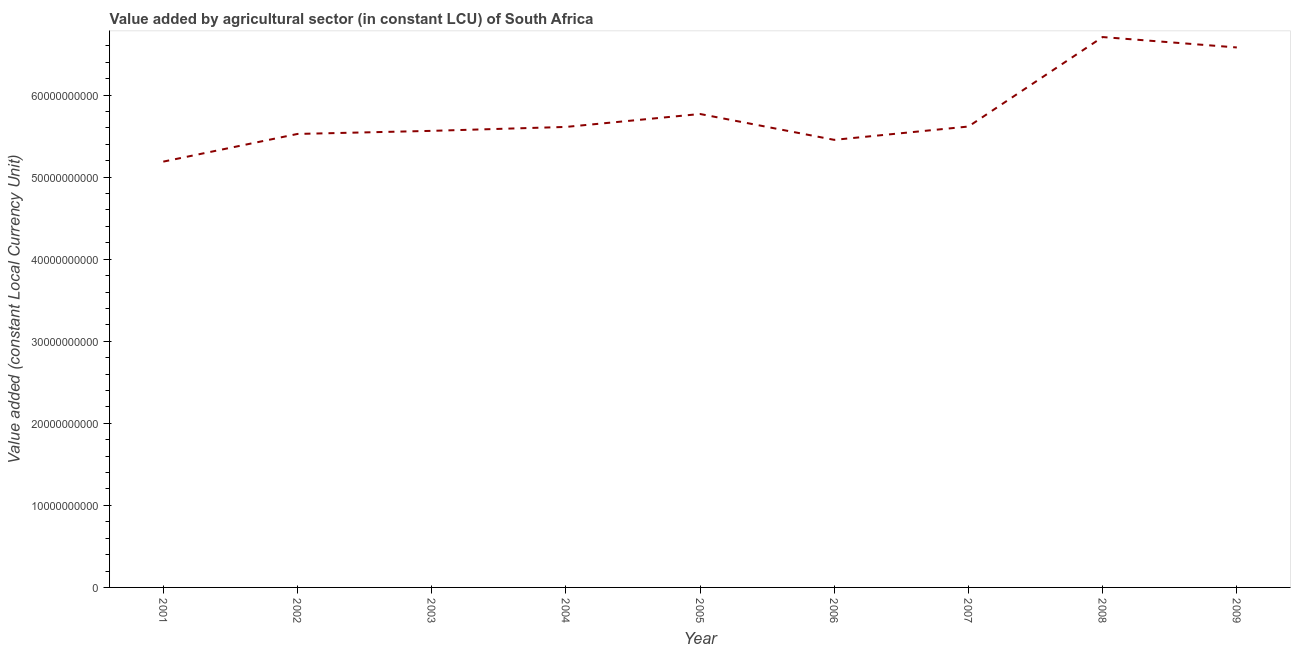What is the value added by agriculture sector in 2009?
Provide a short and direct response. 6.58e+1. Across all years, what is the maximum value added by agriculture sector?
Offer a terse response. 6.71e+1. Across all years, what is the minimum value added by agriculture sector?
Provide a short and direct response. 5.19e+1. In which year was the value added by agriculture sector minimum?
Give a very brief answer. 2001. What is the sum of the value added by agriculture sector?
Provide a succinct answer. 5.20e+11. What is the difference between the value added by agriculture sector in 2003 and 2004?
Make the answer very short. -4.78e+08. What is the average value added by agriculture sector per year?
Your answer should be compact. 5.78e+1. What is the median value added by agriculture sector?
Make the answer very short. 5.61e+1. In how many years, is the value added by agriculture sector greater than 12000000000 LCU?
Keep it short and to the point. 9. What is the ratio of the value added by agriculture sector in 2004 to that in 2007?
Provide a succinct answer. 1. Is the value added by agriculture sector in 2001 less than that in 2007?
Provide a short and direct response. Yes. What is the difference between the highest and the second highest value added by agriculture sector?
Make the answer very short. 1.27e+09. Is the sum of the value added by agriculture sector in 2001 and 2005 greater than the maximum value added by agriculture sector across all years?
Offer a very short reply. Yes. What is the difference between the highest and the lowest value added by agriculture sector?
Provide a short and direct response. 1.52e+1. Does the value added by agriculture sector monotonically increase over the years?
Keep it short and to the point. No. What is the difference between two consecutive major ticks on the Y-axis?
Provide a short and direct response. 1.00e+1. Are the values on the major ticks of Y-axis written in scientific E-notation?
Provide a succinct answer. No. What is the title of the graph?
Offer a very short reply. Value added by agricultural sector (in constant LCU) of South Africa. What is the label or title of the X-axis?
Provide a succinct answer. Year. What is the label or title of the Y-axis?
Your answer should be very brief. Value added (constant Local Currency Unit). What is the Value added (constant Local Currency Unit) in 2001?
Keep it short and to the point. 5.19e+1. What is the Value added (constant Local Currency Unit) in 2002?
Offer a terse response. 5.53e+1. What is the Value added (constant Local Currency Unit) of 2003?
Provide a succinct answer. 5.56e+1. What is the Value added (constant Local Currency Unit) in 2004?
Provide a succinct answer. 5.61e+1. What is the Value added (constant Local Currency Unit) of 2005?
Keep it short and to the point. 5.77e+1. What is the Value added (constant Local Currency Unit) of 2006?
Offer a very short reply. 5.45e+1. What is the Value added (constant Local Currency Unit) in 2007?
Provide a succinct answer. 5.62e+1. What is the Value added (constant Local Currency Unit) in 2008?
Provide a short and direct response. 6.71e+1. What is the Value added (constant Local Currency Unit) of 2009?
Keep it short and to the point. 6.58e+1. What is the difference between the Value added (constant Local Currency Unit) in 2001 and 2002?
Provide a short and direct response. -3.37e+09. What is the difference between the Value added (constant Local Currency Unit) in 2001 and 2003?
Provide a succinct answer. -3.75e+09. What is the difference between the Value added (constant Local Currency Unit) in 2001 and 2004?
Ensure brevity in your answer.  -4.23e+09. What is the difference between the Value added (constant Local Currency Unit) in 2001 and 2005?
Make the answer very short. -5.80e+09. What is the difference between the Value added (constant Local Currency Unit) in 2001 and 2006?
Ensure brevity in your answer.  -2.65e+09. What is the difference between the Value added (constant Local Currency Unit) in 2001 and 2007?
Ensure brevity in your answer.  -4.28e+09. What is the difference between the Value added (constant Local Currency Unit) in 2001 and 2008?
Your response must be concise. -1.52e+1. What is the difference between the Value added (constant Local Currency Unit) in 2001 and 2009?
Your answer should be very brief. -1.39e+1. What is the difference between the Value added (constant Local Currency Unit) in 2002 and 2003?
Provide a succinct answer. -3.76e+08. What is the difference between the Value added (constant Local Currency Unit) in 2002 and 2004?
Your answer should be compact. -8.55e+08. What is the difference between the Value added (constant Local Currency Unit) in 2002 and 2005?
Provide a short and direct response. -2.43e+09. What is the difference between the Value added (constant Local Currency Unit) in 2002 and 2006?
Offer a terse response. 7.20e+08. What is the difference between the Value added (constant Local Currency Unit) in 2002 and 2007?
Offer a terse response. -9.05e+08. What is the difference between the Value added (constant Local Currency Unit) in 2002 and 2008?
Give a very brief answer. -1.18e+1. What is the difference between the Value added (constant Local Currency Unit) in 2002 and 2009?
Offer a very short reply. -1.05e+1. What is the difference between the Value added (constant Local Currency Unit) in 2003 and 2004?
Provide a short and direct response. -4.78e+08. What is the difference between the Value added (constant Local Currency Unit) in 2003 and 2005?
Offer a very short reply. -2.06e+09. What is the difference between the Value added (constant Local Currency Unit) in 2003 and 2006?
Give a very brief answer. 1.10e+09. What is the difference between the Value added (constant Local Currency Unit) in 2003 and 2007?
Provide a short and direct response. -5.28e+08. What is the difference between the Value added (constant Local Currency Unit) in 2003 and 2008?
Keep it short and to the point. -1.14e+1. What is the difference between the Value added (constant Local Currency Unit) in 2003 and 2009?
Ensure brevity in your answer.  -1.02e+1. What is the difference between the Value added (constant Local Currency Unit) in 2004 and 2005?
Keep it short and to the point. -1.58e+09. What is the difference between the Value added (constant Local Currency Unit) in 2004 and 2006?
Keep it short and to the point. 1.57e+09. What is the difference between the Value added (constant Local Currency Unit) in 2004 and 2007?
Provide a succinct answer. -5.00e+07. What is the difference between the Value added (constant Local Currency Unit) in 2004 and 2008?
Your answer should be very brief. -1.10e+1. What is the difference between the Value added (constant Local Currency Unit) in 2004 and 2009?
Keep it short and to the point. -9.68e+09. What is the difference between the Value added (constant Local Currency Unit) in 2005 and 2006?
Your response must be concise. 3.15e+09. What is the difference between the Value added (constant Local Currency Unit) in 2005 and 2007?
Give a very brief answer. 1.53e+09. What is the difference between the Value added (constant Local Currency Unit) in 2005 and 2008?
Your response must be concise. -9.38e+09. What is the difference between the Value added (constant Local Currency Unit) in 2005 and 2009?
Make the answer very short. -8.11e+09. What is the difference between the Value added (constant Local Currency Unit) in 2006 and 2007?
Offer a terse response. -1.62e+09. What is the difference between the Value added (constant Local Currency Unit) in 2006 and 2008?
Offer a terse response. -1.25e+1. What is the difference between the Value added (constant Local Currency Unit) in 2006 and 2009?
Offer a terse response. -1.13e+1. What is the difference between the Value added (constant Local Currency Unit) in 2007 and 2008?
Provide a succinct answer. -1.09e+1. What is the difference between the Value added (constant Local Currency Unit) in 2007 and 2009?
Offer a terse response. -9.63e+09. What is the difference between the Value added (constant Local Currency Unit) in 2008 and 2009?
Offer a very short reply. 1.27e+09. What is the ratio of the Value added (constant Local Currency Unit) in 2001 to that in 2002?
Offer a terse response. 0.94. What is the ratio of the Value added (constant Local Currency Unit) in 2001 to that in 2003?
Give a very brief answer. 0.93. What is the ratio of the Value added (constant Local Currency Unit) in 2001 to that in 2004?
Offer a terse response. 0.93. What is the ratio of the Value added (constant Local Currency Unit) in 2001 to that in 2005?
Provide a succinct answer. 0.9. What is the ratio of the Value added (constant Local Currency Unit) in 2001 to that in 2006?
Provide a succinct answer. 0.95. What is the ratio of the Value added (constant Local Currency Unit) in 2001 to that in 2007?
Provide a short and direct response. 0.92. What is the ratio of the Value added (constant Local Currency Unit) in 2001 to that in 2008?
Your response must be concise. 0.77. What is the ratio of the Value added (constant Local Currency Unit) in 2001 to that in 2009?
Make the answer very short. 0.79. What is the ratio of the Value added (constant Local Currency Unit) in 2002 to that in 2003?
Provide a succinct answer. 0.99. What is the ratio of the Value added (constant Local Currency Unit) in 2002 to that in 2004?
Give a very brief answer. 0.98. What is the ratio of the Value added (constant Local Currency Unit) in 2002 to that in 2005?
Your response must be concise. 0.96. What is the ratio of the Value added (constant Local Currency Unit) in 2002 to that in 2008?
Provide a short and direct response. 0.82. What is the ratio of the Value added (constant Local Currency Unit) in 2002 to that in 2009?
Offer a very short reply. 0.84. What is the ratio of the Value added (constant Local Currency Unit) in 2003 to that in 2004?
Provide a succinct answer. 0.99. What is the ratio of the Value added (constant Local Currency Unit) in 2003 to that in 2007?
Keep it short and to the point. 0.99. What is the ratio of the Value added (constant Local Currency Unit) in 2003 to that in 2008?
Your answer should be compact. 0.83. What is the ratio of the Value added (constant Local Currency Unit) in 2003 to that in 2009?
Your answer should be compact. 0.85. What is the ratio of the Value added (constant Local Currency Unit) in 2004 to that in 2006?
Your answer should be compact. 1.03. What is the ratio of the Value added (constant Local Currency Unit) in 2004 to that in 2007?
Offer a terse response. 1. What is the ratio of the Value added (constant Local Currency Unit) in 2004 to that in 2008?
Offer a very short reply. 0.84. What is the ratio of the Value added (constant Local Currency Unit) in 2004 to that in 2009?
Make the answer very short. 0.85. What is the ratio of the Value added (constant Local Currency Unit) in 2005 to that in 2006?
Make the answer very short. 1.06. What is the ratio of the Value added (constant Local Currency Unit) in 2005 to that in 2008?
Offer a very short reply. 0.86. What is the ratio of the Value added (constant Local Currency Unit) in 2005 to that in 2009?
Your response must be concise. 0.88. What is the ratio of the Value added (constant Local Currency Unit) in 2006 to that in 2007?
Offer a very short reply. 0.97. What is the ratio of the Value added (constant Local Currency Unit) in 2006 to that in 2008?
Your answer should be very brief. 0.81. What is the ratio of the Value added (constant Local Currency Unit) in 2006 to that in 2009?
Ensure brevity in your answer.  0.83. What is the ratio of the Value added (constant Local Currency Unit) in 2007 to that in 2008?
Offer a terse response. 0.84. What is the ratio of the Value added (constant Local Currency Unit) in 2007 to that in 2009?
Offer a terse response. 0.85. 